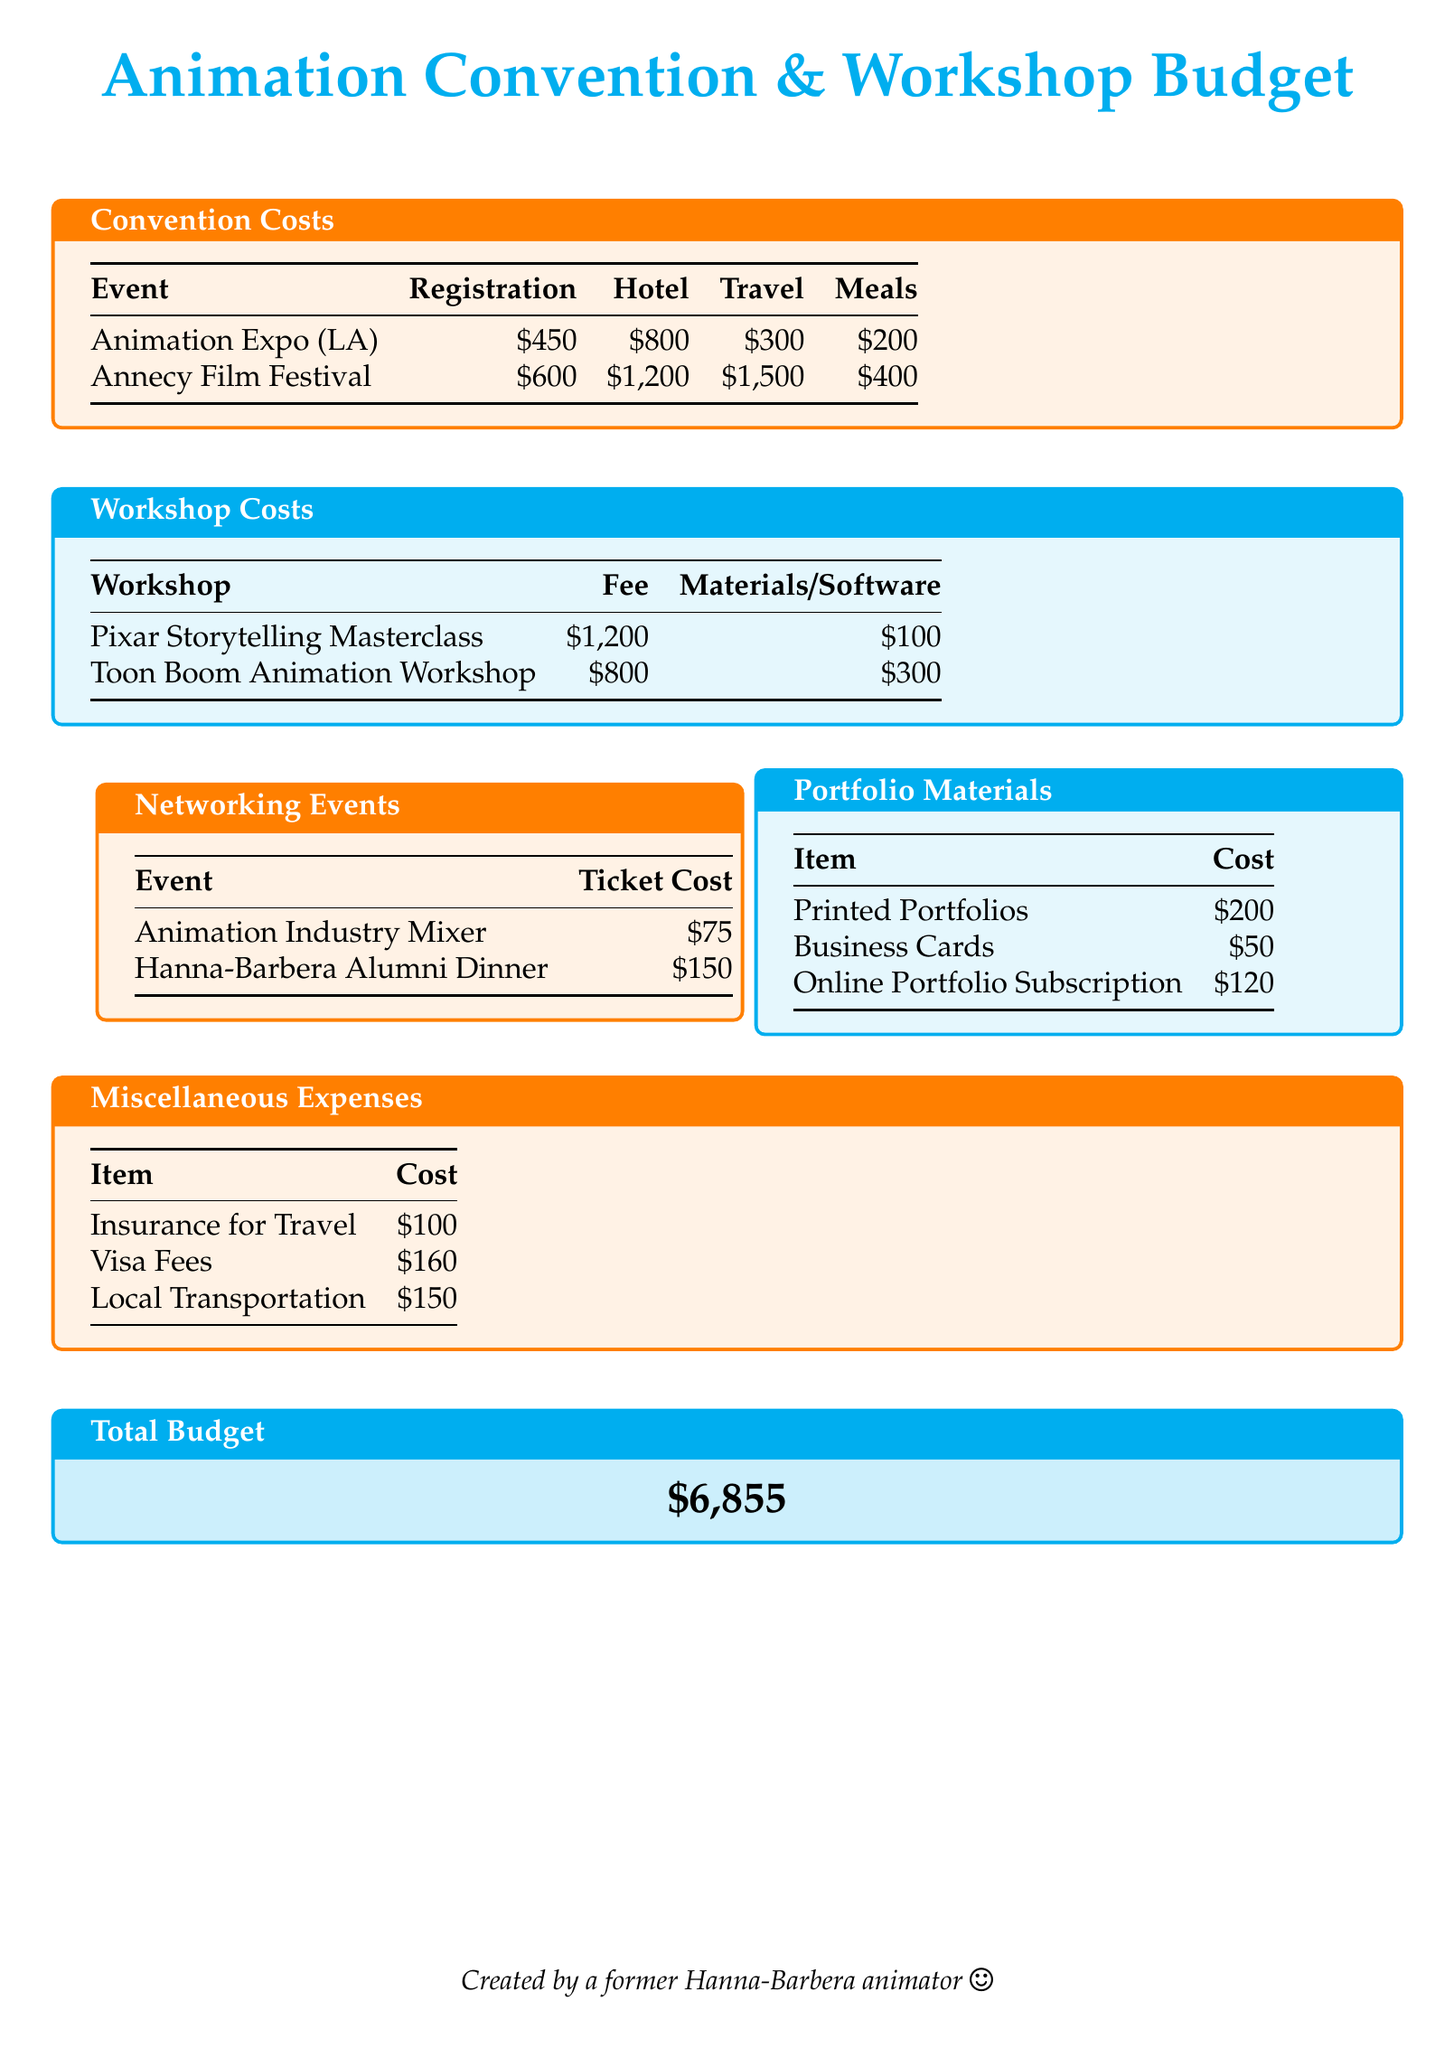what is the total budget? The total budget is presented at the end of the document as the cumulative sum of all costs listed.
Answer: $6,855 how much does the Annecy Film Festival cost for travel? The travel cost associated with attending the Annecy Film Festival is specifically highlighted in the costs table.
Answer: $1,500 what is the fee for the Pixar Storytelling Masterclass? The fee for the Pixar Storytelling Masterclass is directly stated in the workshop costs section of the document.
Answer: $1,200 how much do printed portfolios cost? The document lists the cost of printed portfolios in the portfolio materials section.
Answer: $200 how many networking events are mentioned in the document? The document provides a count of distinct networking events listed, indicating the number present.
Answer: 2 what is the hotel cost for Animation Expo in LA? The hotel cost for attending the Animation Expo is specified directly in the convention costs section.
Answer: $800 what is the cost of business cards? The cost of business cards is detailed under the portfolio materials section.
Answer: $50 what is the total cost for attending the Toon Boom Animation Workshop? To calculate this, we need to add the fee and materials cost provided for the Toon Boom Animation Workshop.
Answer: $1,100 how much is local transportation listed as a miscellaneous expense? The cost for local transportation is noted in the miscellaneous expenses section of the document.
Answer: $150 